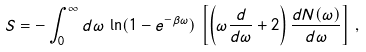Convert formula to latex. <formula><loc_0><loc_0><loc_500><loc_500>S = - \int _ { 0 } ^ { \infty } d \omega \, \ln ( 1 - e ^ { - \beta \omega } ) \, \left [ \left ( \omega \frac { d } { d \omega } + 2 \right ) \frac { d N ( \omega ) } { d \omega } \right ] \, ,</formula> 